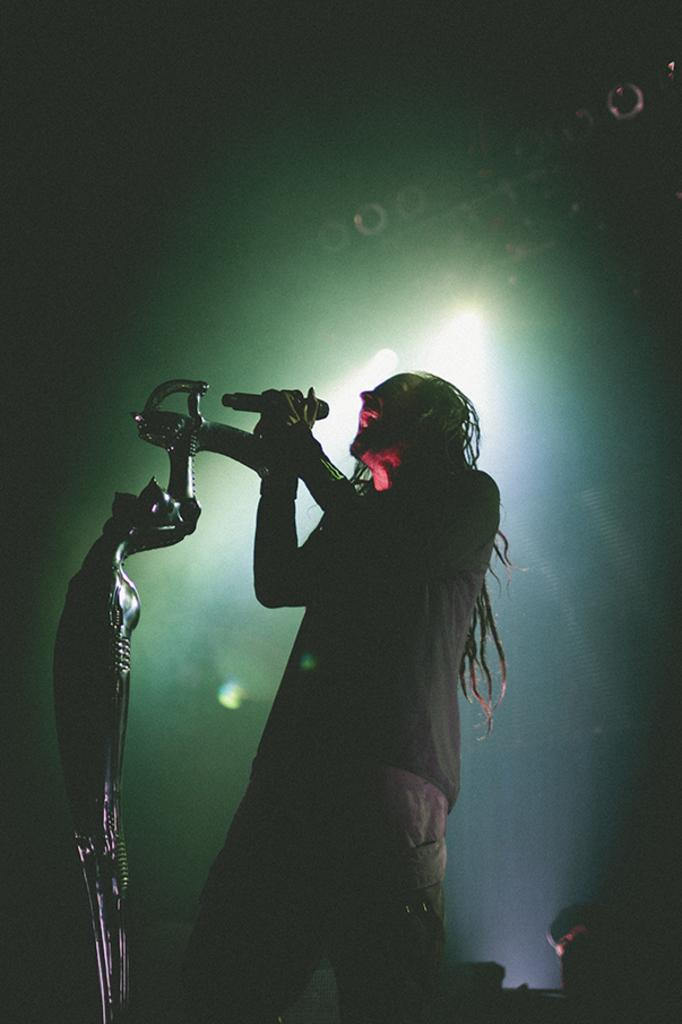What is the main subject of the image? There is a man standing in the image. What object is located on the left side of the image? There is a microphone on the left side of the image. What can be seen in the background of the image? There are lights in the background of the image. How would you describe the overall lighting in the image? The background of the image is dark. What type of canvas is the man painting in the image? There is no canvas or painting activity present in the image. How many fangs can be seen on the man in the image? There are no fangs visible on the man in the image. 